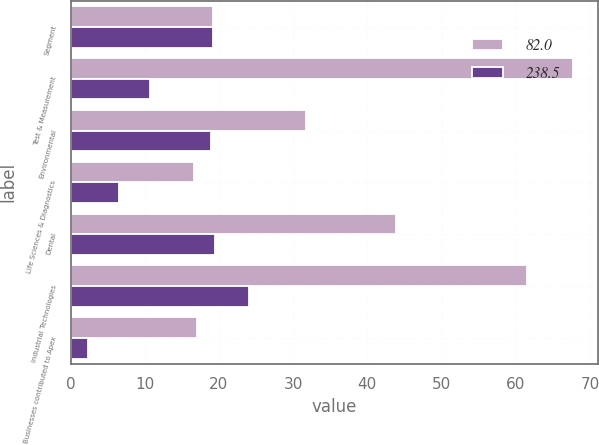<chart> <loc_0><loc_0><loc_500><loc_500><stacked_bar_chart><ecel><fcel>Segment<fcel>Test & Measurement<fcel>Environmental<fcel>Life Sciences & Diagnostics<fcel>Dental<fcel>Industrial Technologies<fcel>Businesses contributed to Apex<nl><fcel>82<fcel>19.2<fcel>67.7<fcel>31.7<fcel>16.7<fcel>43.8<fcel>61.5<fcel>17.1<nl><fcel>238.5<fcel>19.2<fcel>10.7<fcel>18.9<fcel>6.6<fcel>19.5<fcel>24<fcel>2.3<nl></chart> 